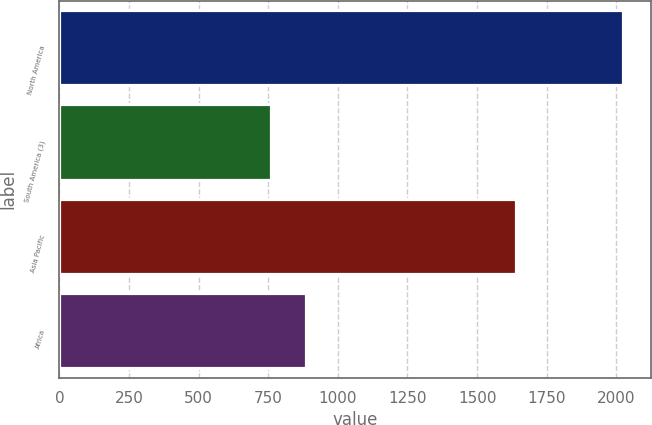<chart> <loc_0><loc_0><loc_500><loc_500><bar_chart><fcel>North America<fcel>South America (3)<fcel>Asia Pacific<fcel>Africa<nl><fcel>2024<fcel>759<fcel>1641<fcel>885.5<nl></chart> 